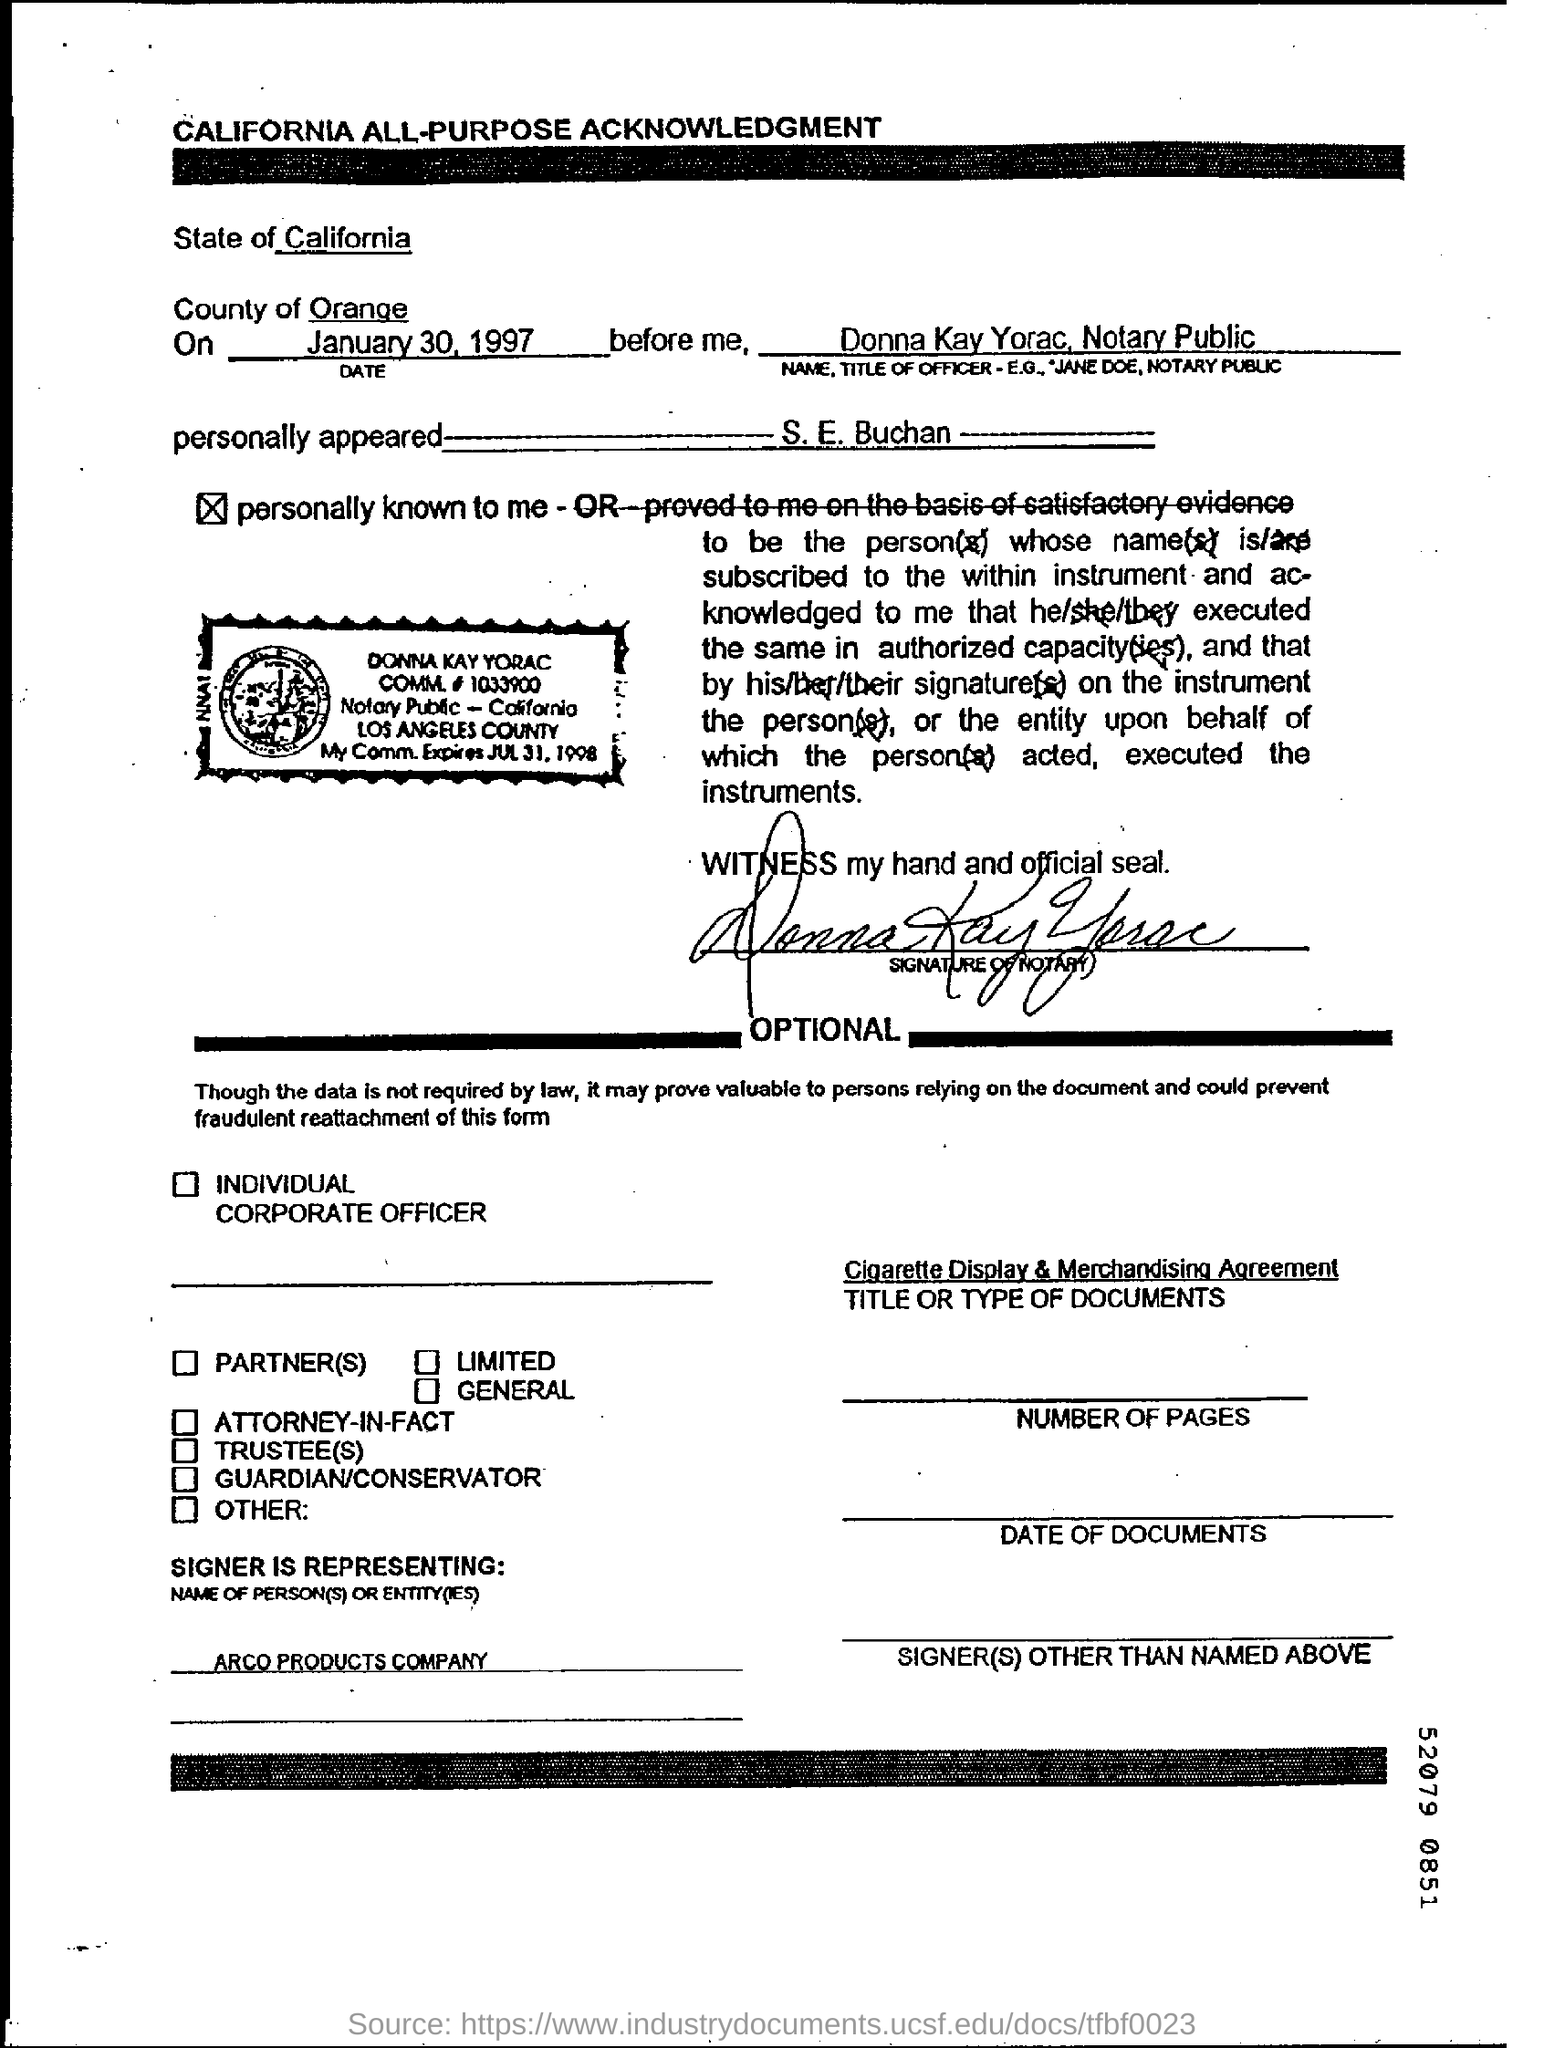What is written in the letter head ?
Keep it short and to the point. California All-Purpose Acknowledgement. What is the date mentioned in the top of the document ?
Keep it short and to the point. January 30, 1997. 